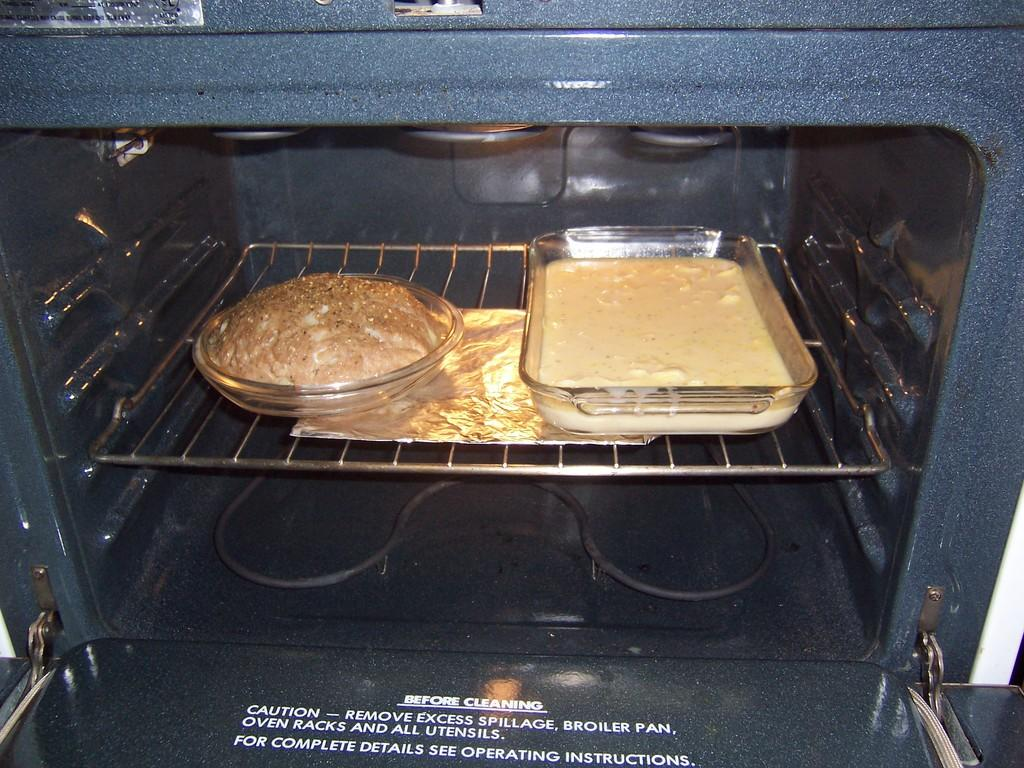Provide a one-sentence caption for the provided image. An open oven with instructions on what to do before cleaning. 